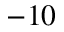<formula> <loc_0><loc_0><loc_500><loc_500>- 1 0</formula> 